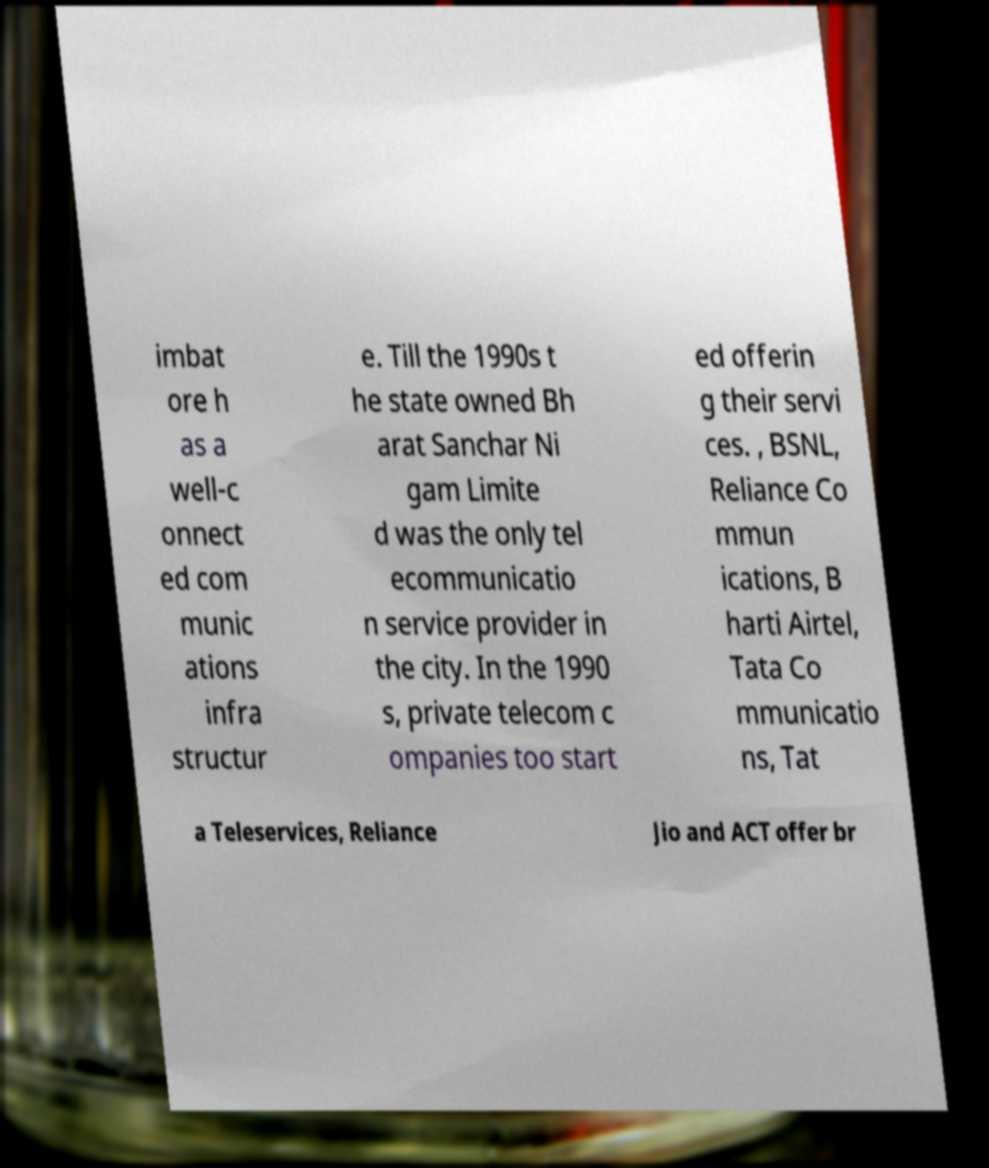Please read and relay the text visible in this image. What does it say? imbat ore h as a well-c onnect ed com munic ations infra structur e. Till the 1990s t he state owned Bh arat Sanchar Ni gam Limite d was the only tel ecommunicatio n service provider in the city. In the 1990 s, private telecom c ompanies too start ed offerin g their servi ces. , BSNL, Reliance Co mmun ications, B harti Airtel, Tata Co mmunicatio ns, Tat a Teleservices, Reliance Jio and ACT offer br 